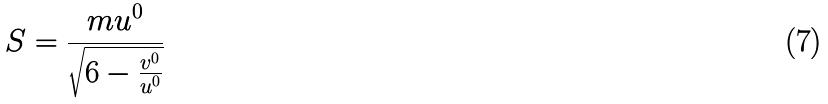<formula> <loc_0><loc_0><loc_500><loc_500>S = \frac { m u ^ { 0 } } { \sqrt { 6 - \frac { v ^ { 0 } } { u ^ { 0 } } } }</formula> 